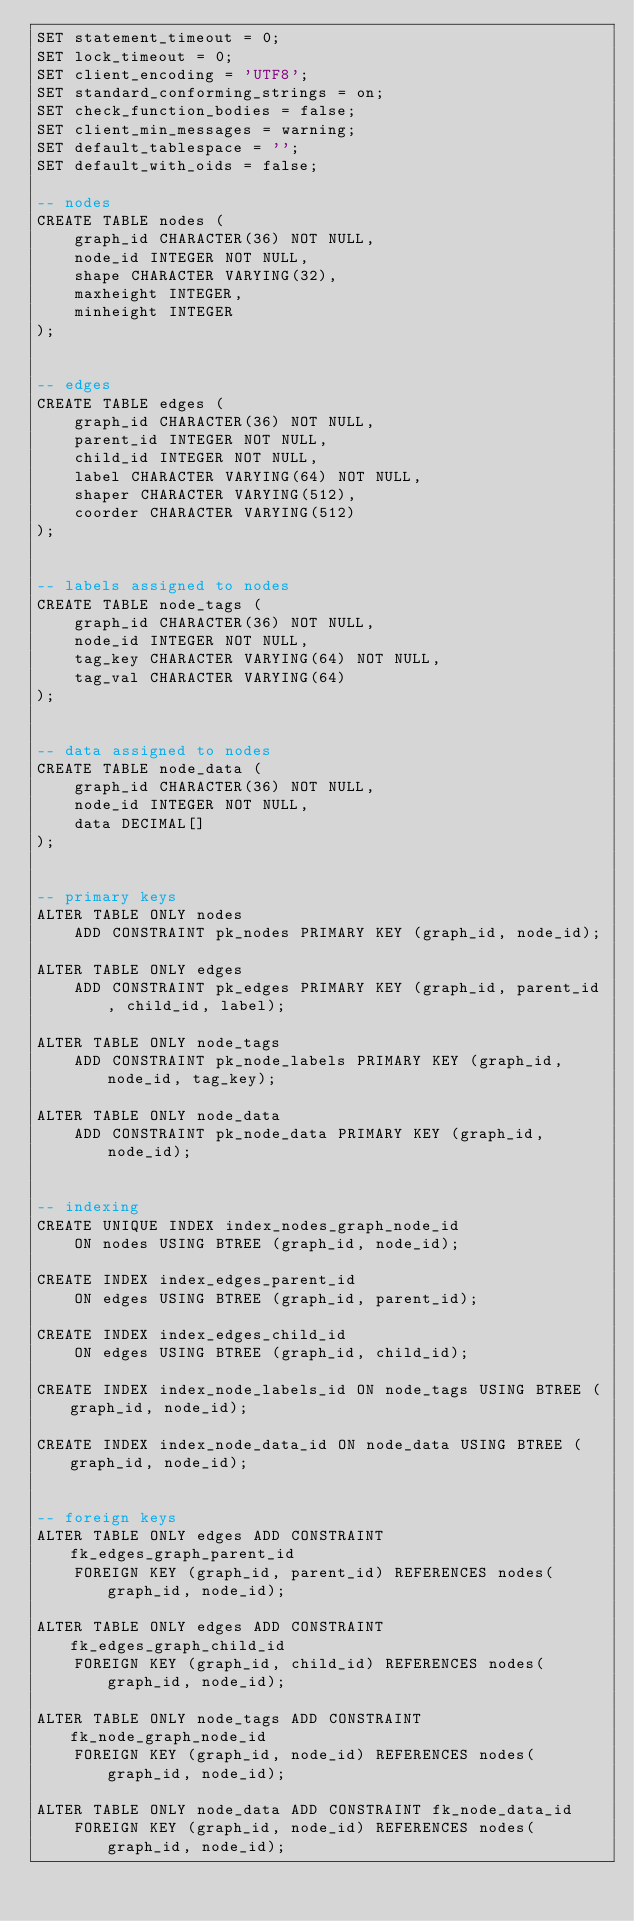Convert code to text. <code><loc_0><loc_0><loc_500><loc_500><_SQL_>SET statement_timeout = 0;
SET lock_timeout = 0;
SET client_encoding = 'UTF8';
SET standard_conforming_strings = on;
SET check_function_bodies = false;
SET client_min_messages = warning;
SET default_tablespace = '';
SET default_with_oids = false;

-- nodes
CREATE TABLE nodes (
    graph_id CHARACTER(36) NOT NULL,
    node_id INTEGER NOT NULL,
    shape CHARACTER VARYING(32),
    maxheight INTEGER,
    minheight INTEGER
);


-- edges
CREATE TABLE edges (
    graph_id CHARACTER(36) NOT NULL,
    parent_id INTEGER NOT NULL,
    child_id INTEGER NOT NULL,
    label CHARACTER VARYING(64) NOT NULL,
    shaper CHARACTER VARYING(512),
    coorder CHARACTER VARYING(512)
);


-- labels assigned to nodes
CREATE TABLE node_tags (
    graph_id CHARACTER(36) NOT NULL,
    node_id INTEGER NOT NULL,
    tag_key CHARACTER VARYING(64) NOT NULL,
    tag_val CHARACTER VARYING(64)
);


-- data assigned to nodes
CREATE TABLE node_data (
    graph_id CHARACTER(36) NOT NULL,
    node_id INTEGER NOT NULL,
    data DECIMAL[]
);


-- primary keys
ALTER TABLE ONLY nodes
    ADD CONSTRAINT pk_nodes PRIMARY KEY (graph_id, node_id);

ALTER TABLE ONLY edges
    ADD CONSTRAINT pk_edges PRIMARY KEY (graph_id, parent_id, child_id, label);

ALTER TABLE ONLY node_tags
    ADD CONSTRAINT pk_node_labels PRIMARY KEY (graph_id, node_id, tag_key);

ALTER TABLE ONLY node_data
    ADD CONSTRAINT pk_node_data PRIMARY KEY (graph_id, node_id);


-- indexing
CREATE UNIQUE INDEX index_nodes_graph_node_id
    ON nodes USING BTREE (graph_id, node_id);

CREATE INDEX index_edges_parent_id
    ON edges USING BTREE (graph_id, parent_id);

CREATE INDEX index_edges_child_id
    ON edges USING BTREE (graph_id, child_id);

CREATE INDEX index_node_labels_id ON node_tags USING BTREE (graph_id, node_id);

CREATE INDEX index_node_data_id ON node_data USING BTREE (graph_id, node_id);


-- foreign keys
ALTER TABLE ONLY edges ADD CONSTRAINT fk_edges_graph_parent_id
    FOREIGN KEY (graph_id, parent_id) REFERENCES nodes(graph_id, node_id);

ALTER TABLE ONLY edges ADD CONSTRAINT fk_edges_graph_child_id
    FOREIGN KEY (graph_id, child_id) REFERENCES nodes(graph_id, node_id);

ALTER TABLE ONLY node_tags ADD CONSTRAINT fk_node_graph_node_id
    FOREIGN KEY (graph_id, node_id) REFERENCES nodes(graph_id, node_id);

ALTER TABLE ONLY node_data ADD CONSTRAINT fk_node_data_id
    FOREIGN KEY (graph_id, node_id) REFERENCES nodes(graph_id, node_id);
</code> 